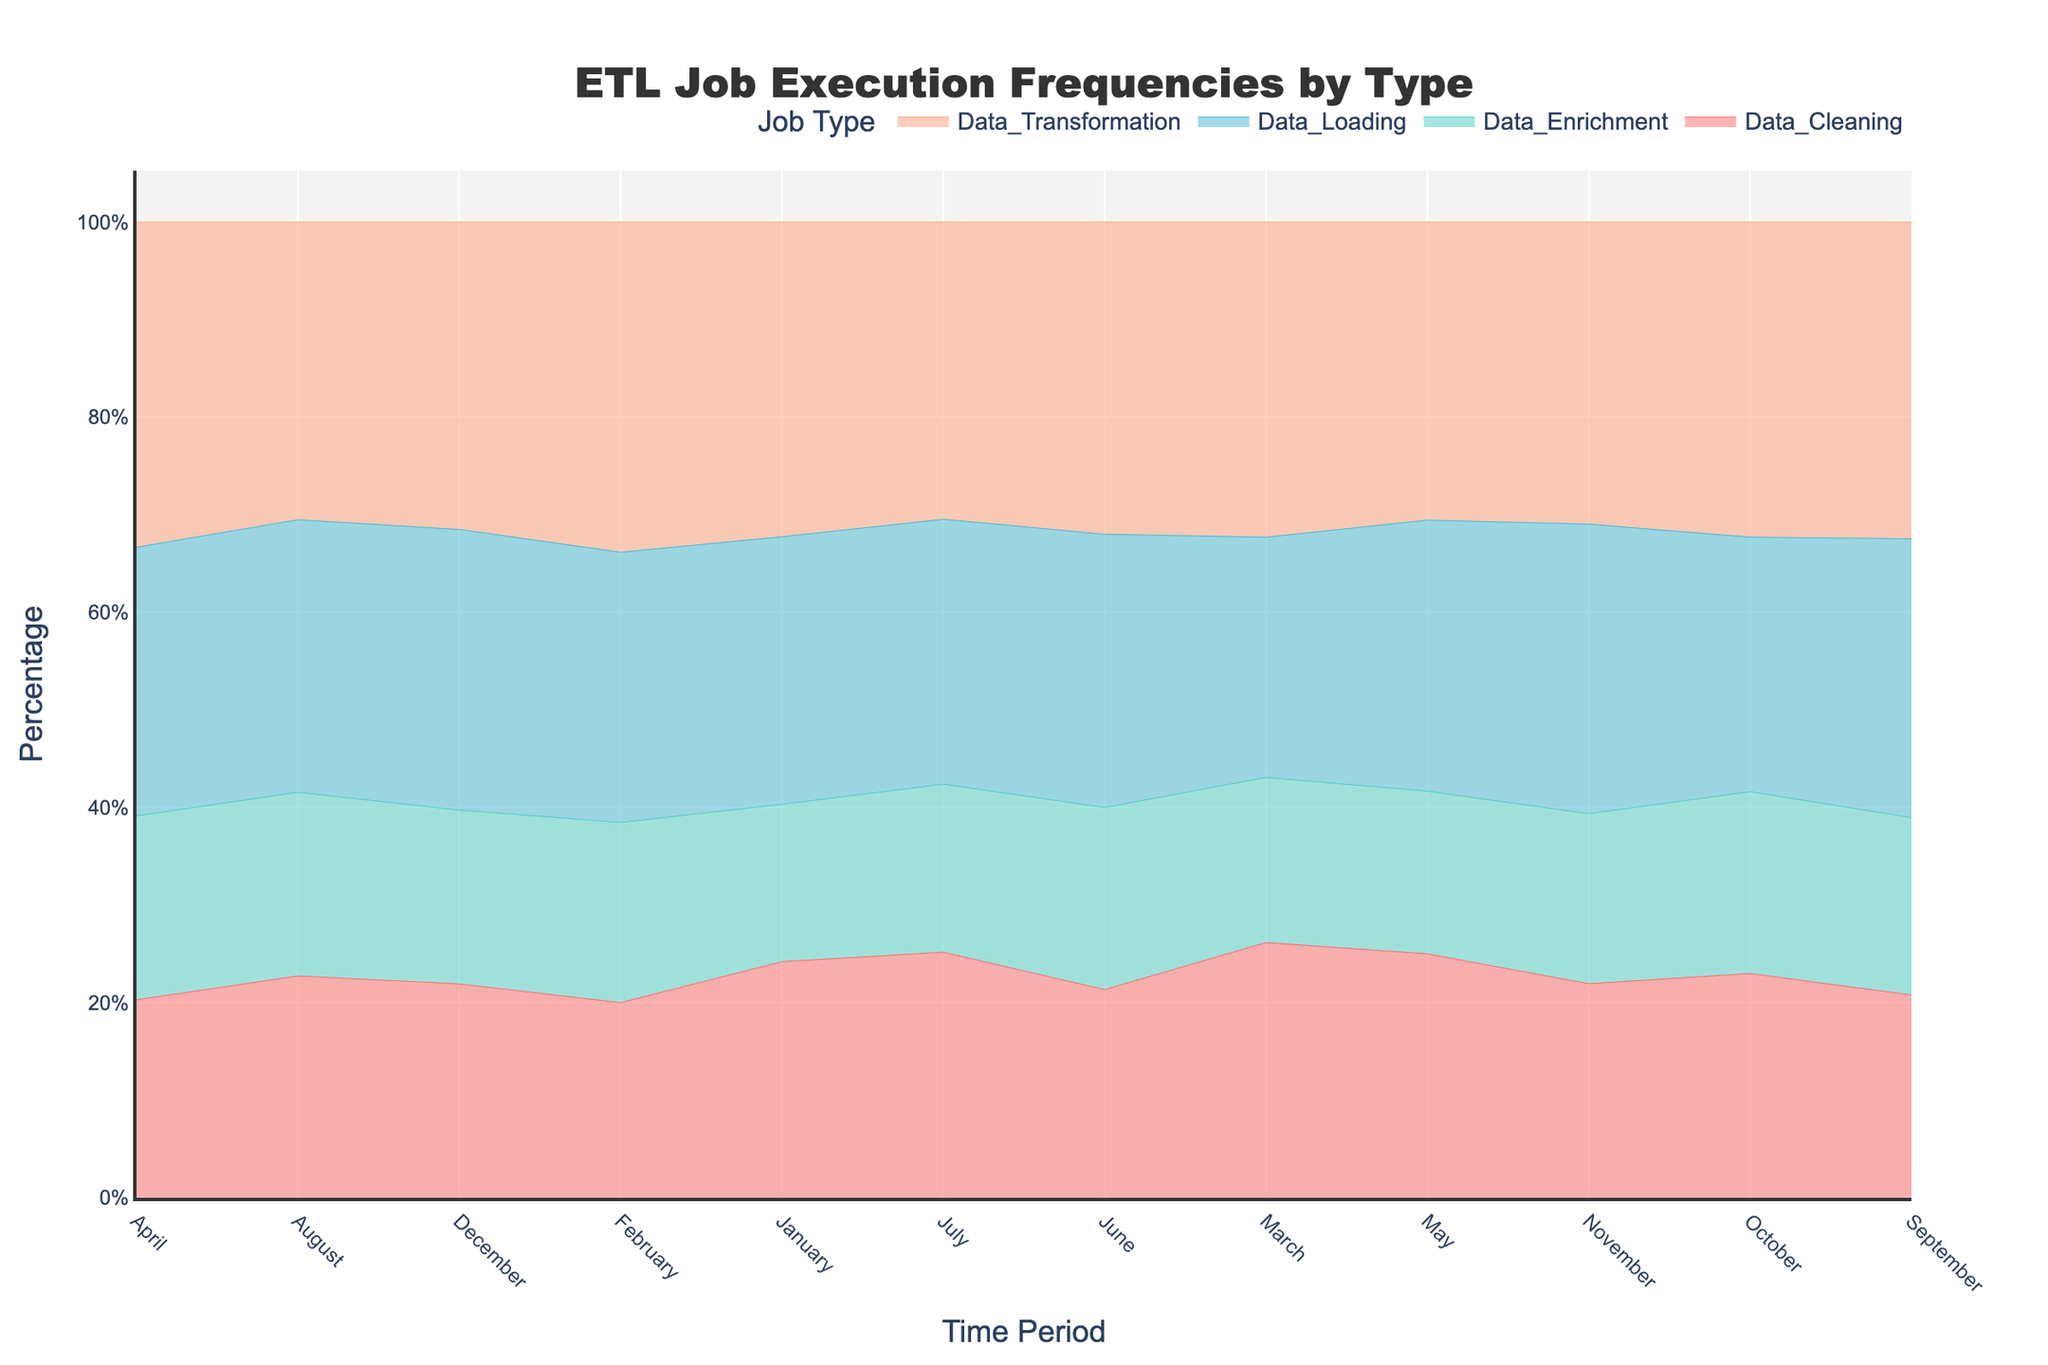Which job type has the highest execution frequency in January? In January, the highest segment is the one for Data Transformation, indicating it has the highest execution frequency for that month.
Answer: Data Transformation What percentage of the total execution frequency does Data Loading occupy in May? In May, Data Transformation is at the top, followed by Data Loading, Data Cleaning, and Data Enrichment. Data Loading occupies approximately 30% of the total.
Answer: 30% During which time period did Data Enrichment have the lowest percentage share? By examining each month's Data Enrichment segment, it is smallest in January at 10%, compared to other months where it is slightly higher.
Answer: January Which job type showed a general increasing trend across the time periods? Observing the trend lines for each job type, Data Transformation shows an increasing overall trend, culminating in its highest percentages towards the end of the year.
Answer: Data Transformation Compare the percentage share of Data Cleaning in March and November. Which month had a higher percentage? In March, Data Cleaning occupies a smaller portion of the stack compared to November. Thus, Data Cleaning had a higher percentage share in November.
Answer: November What is the approximate percentage difference between the highest and lowest frequency month for Data Transformation? The highest frequency percentage for Data Transformation is in October (26%) and the lowest is in February (22%). Therefore, the approximate percentage difference is 4%.
Answer: 4% In October, what is the order from highest to lowest of the job types by percentage share? For October, the order from highest to lowest percentage share is Data Transformation, Data Loading, Data Cleaning, and Data Enrichment.
Answer: Data Transformation, Data Loading, Data Cleaning, Data Enrichment During which month did Data Loading surpass Data Transformation in percentage share? By observing the stacks, Data Loading surpassed Data Transformation only in January.
Answer: January Is there any month where Data Enrichment and Data Cleaning have equal percentage shares? No month shows Data Enrichment and Data Cleaning having equal percentage shares, indicated by the non-overlapping segments in the stacked area chart.
Answer: No 